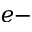<formula> <loc_0><loc_0><loc_500><loc_500>e -</formula> 